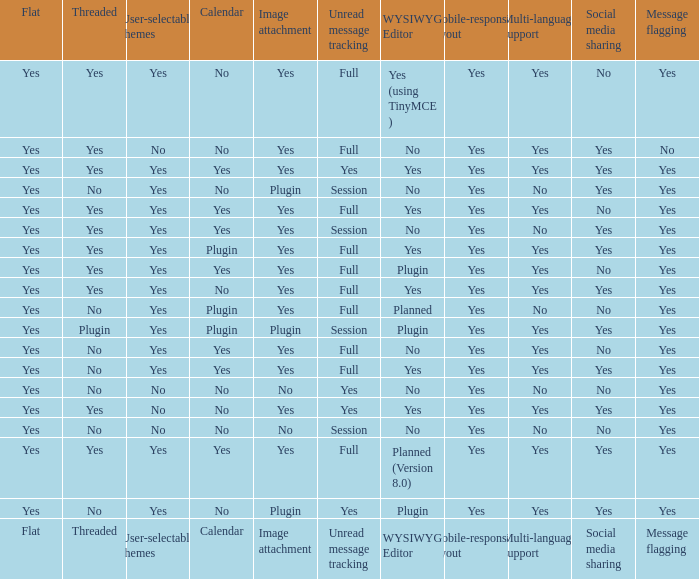Which Calendar has a User-selectable themes of user-selectable themes? Calendar. 